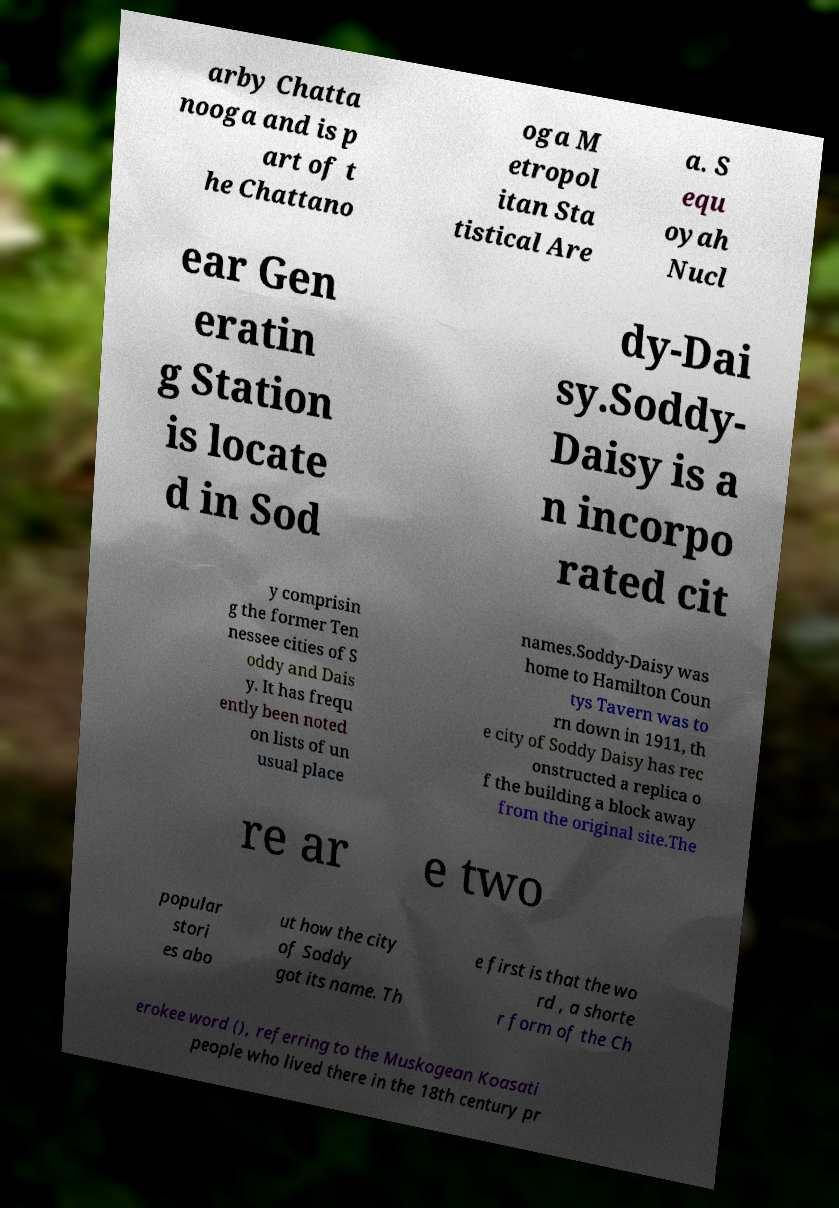I need the written content from this picture converted into text. Can you do that? arby Chatta nooga and is p art of t he Chattano oga M etropol itan Sta tistical Are a. S equ oyah Nucl ear Gen eratin g Station is locate d in Sod dy-Dai sy.Soddy- Daisy is a n incorpo rated cit y comprisin g the former Ten nessee cities of S oddy and Dais y. It has frequ ently been noted on lists of un usual place names.Soddy-Daisy was home to Hamilton Coun tys Tavern was to rn down in 1911, th e city of Soddy Daisy has rec onstructed a replica o f the building a block away from the original site.The re ar e two popular stori es abo ut how the city of Soddy got its name. Th e first is that the wo rd , a shorte r form of the Ch erokee word (), referring to the Muskogean Koasati people who lived there in the 18th century pr 